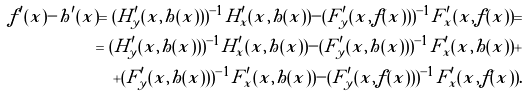Convert formula to latex. <formula><loc_0><loc_0><loc_500><loc_500>f ^ { \prime } ( x ) - h ^ { \prime } ( x ) = ( H ^ { \prime } _ { y } ( x , h ( x ) ) ) ^ { - 1 } H ^ { \prime } _ { x } ( x , h ( x ) ) - ( F ^ { \prime } _ { y } ( x , f ( x ) ) ) ^ { - 1 } F ^ { \prime } _ { x } ( x , f ( x ) ) = \\ = ( H ^ { \prime } _ { y } ( x , h ( x ) ) ) ^ { - 1 } H ^ { \prime } _ { x } ( x , h ( x ) ) - ( F ^ { \prime } _ { y } ( x , h ( x ) ) ) ^ { - 1 } F ^ { \prime } _ { x } ( x , h ( x ) ) + \\ + ( F ^ { \prime } _ { y } ( x , h ( x ) ) ) ^ { - 1 } F ^ { \prime } _ { x } ( x , h ( x ) ) - ( F ^ { \prime } _ { y } ( x , f ( x ) ) ) ^ { - 1 } F ^ { \prime } _ { x } ( x , f ( x ) ) .</formula> 